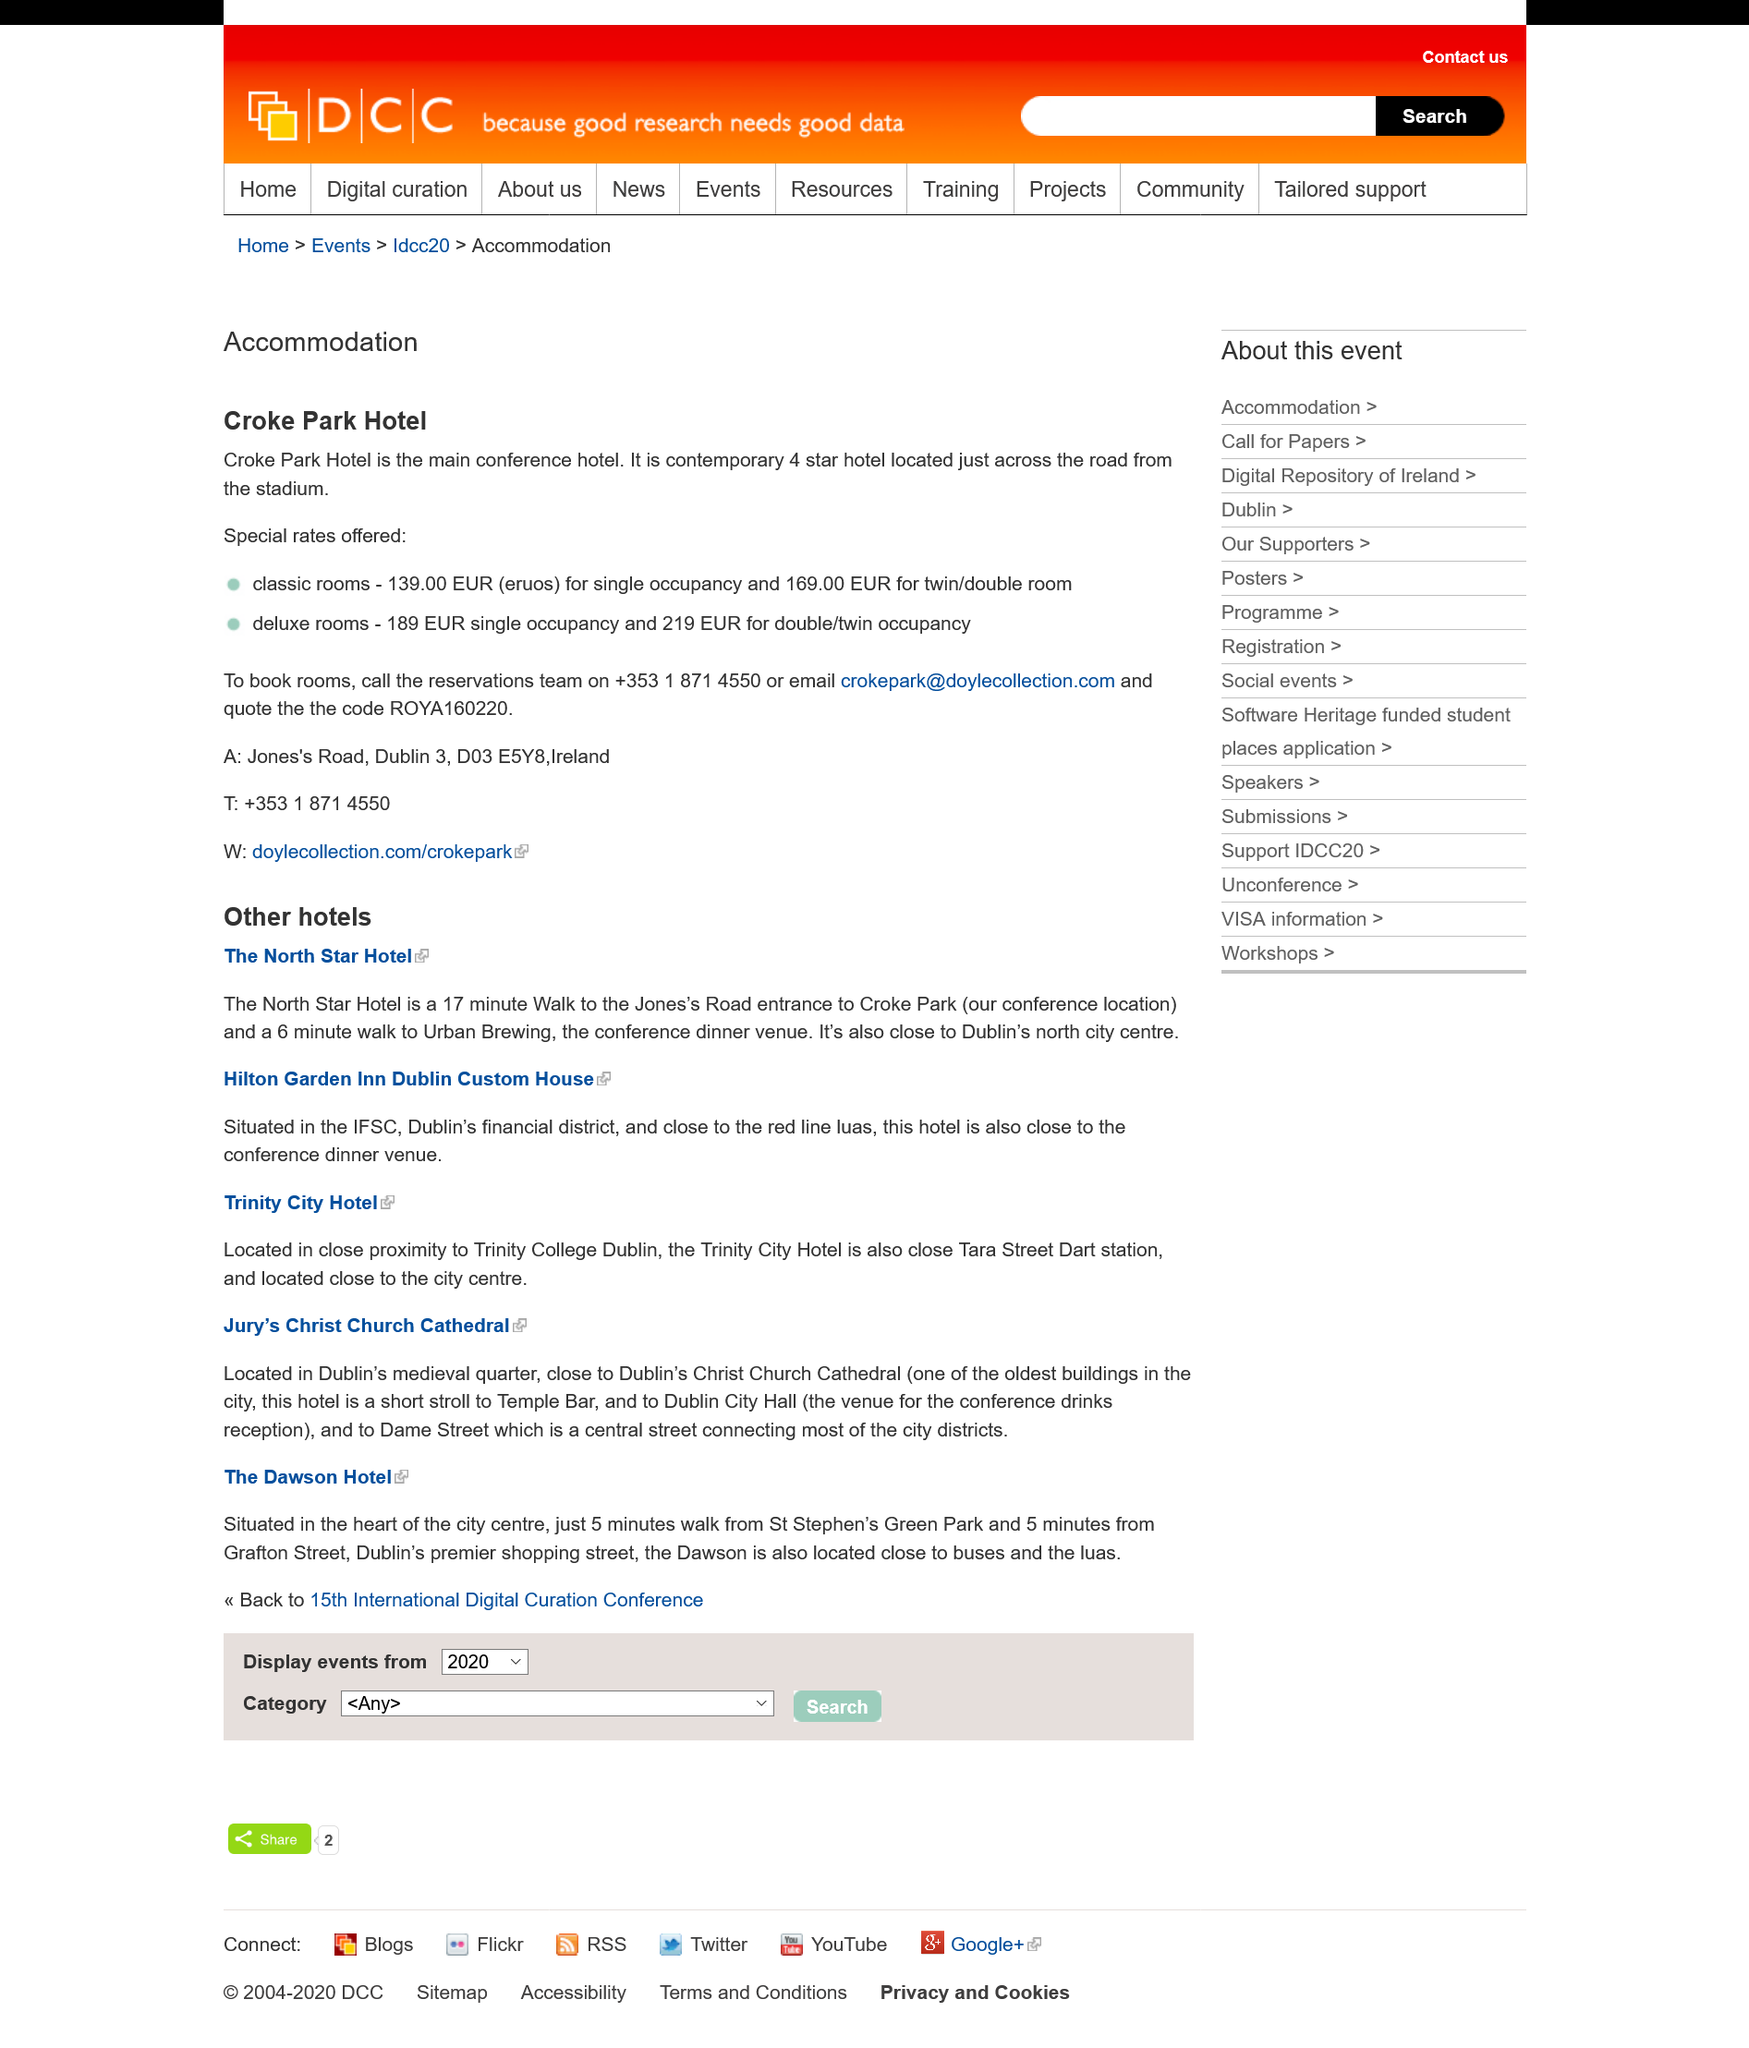Point out several critical features in this image. The specified hotels are situated in Dublin, the capital city of the Republic of Ireland. The Hilton Garden Inn Dublin Custom House is located in the financial district of Dublin and is situated in close proximity to the city's major financial institutions. Trinity City Hotel is conveniently located near Trinity College Dublin, making it an ideal choice for visitors seeking easy access to the many cultural and educational attractions of the area. 